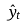<formula> <loc_0><loc_0><loc_500><loc_500>\hat { y } _ { t }</formula> 